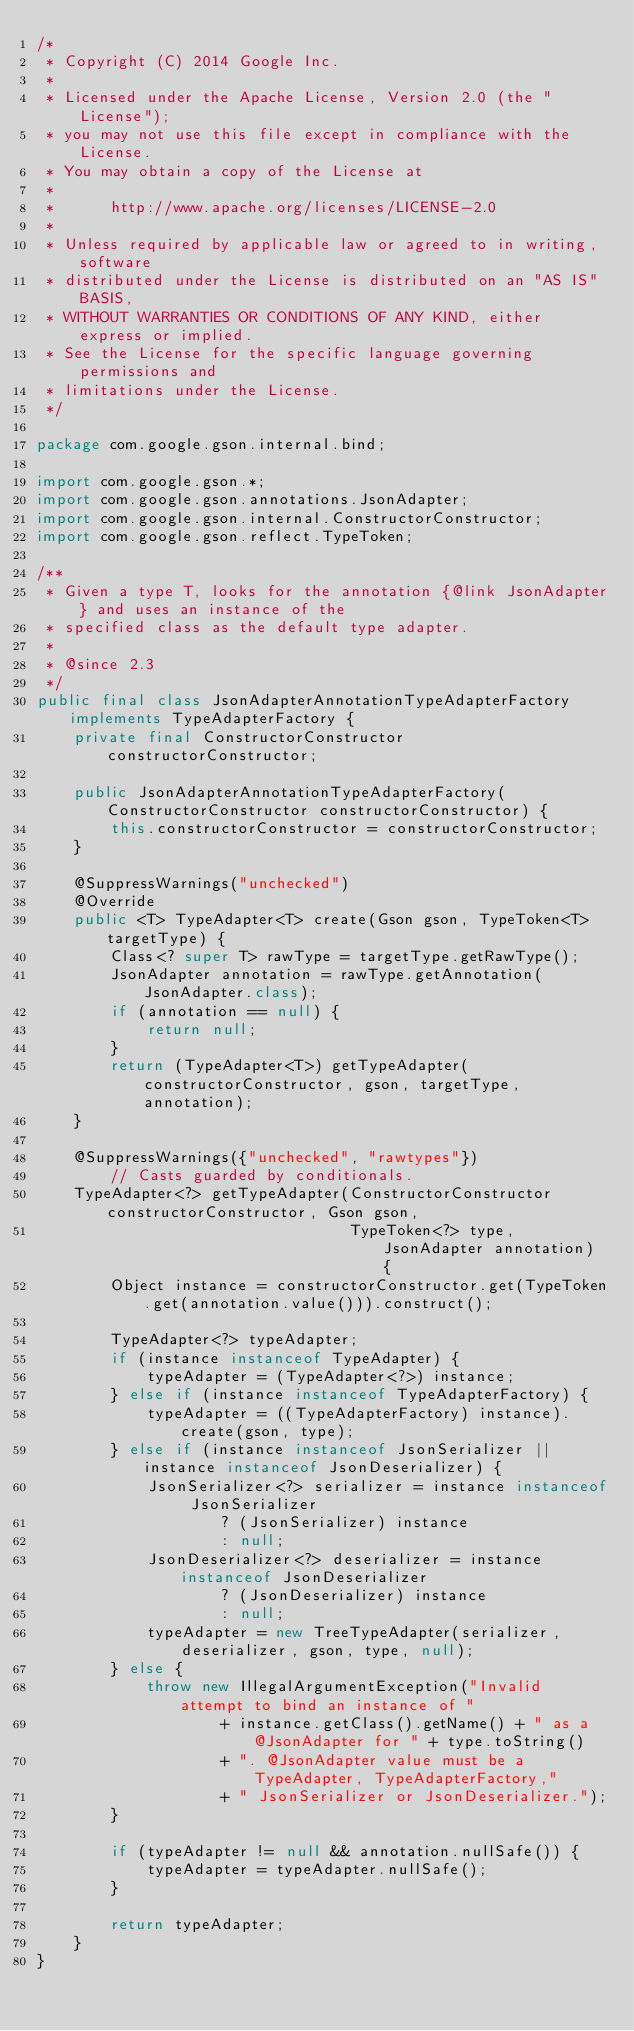Convert code to text. <code><loc_0><loc_0><loc_500><loc_500><_Java_>/*
 * Copyright (C) 2014 Google Inc.
 *
 * Licensed under the Apache License, Version 2.0 (the "License");
 * you may not use this file except in compliance with the License.
 * You may obtain a copy of the License at
 *
 *      http://www.apache.org/licenses/LICENSE-2.0
 *
 * Unless required by applicable law or agreed to in writing, software
 * distributed under the License is distributed on an "AS IS" BASIS,
 * WITHOUT WARRANTIES OR CONDITIONS OF ANY KIND, either express or implied.
 * See the License for the specific language governing permissions and
 * limitations under the License.
 */

package com.google.gson.internal.bind;

import com.google.gson.*;
import com.google.gson.annotations.JsonAdapter;
import com.google.gson.internal.ConstructorConstructor;
import com.google.gson.reflect.TypeToken;

/**
 * Given a type T, looks for the annotation {@link JsonAdapter} and uses an instance of the
 * specified class as the default type adapter.
 *
 * @since 2.3
 */
public final class JsonAdapterAnnotationTypeAdapterFactory implements TypeAdapterFactory {
    private final ConstructorConstructor constructorConstructor;

    public JsonAdapterAnnotationTypeAdapterFactory(ConstructorConstructor constructorConstructor) {
        this.constructorConstructor = constructorConstructor;
    }

    @SuppressWarnings("unchecked")
    @Override
    public <T> TypeAdapter<T> create(Gson gson, TypeToken<T> targetType) {
        Class<? super T> rawType = targetType.getRawType();
        JsonAdapter annotation = rawType.getAnnotation(JsonAdapter.class);
        if (annotation == null) {
            return null;
        }
        return (TypeAdapter<T>) getTypeAdapter(constructorConstructor, gson, targetType, annotation);
    }

    @SuppressWarnings({"unchecked", "rawtypes"})
        // Casts guarded by conditionals.
    TypeAdapter<?> getTypeAdapter(ConstructorConstructor constructorConstructor, Gson gson,
                                  TypeToken<?> type, JsonAdapter annotation) {
        Object instance = constructorConstructor.get(TypeToken.get(annotation.value())).construct();

        TypeAdapter<?> typeAdapter;
        if (instance instanceof TypeAdapter) {
            typeAdapter = (TypeAdapter<?>) instance;
        } else if (instance instanceof TypeAdapterFactory) {
            typeAdapter = ((TypeAdapterFactory) instance).create(gson, type);
        } else if (instance instanceof JsonSerializer || instance instanceof JsonDeserializer) {
            JsonSerializer<?> serializer = instance instanceof JsonSerializer
                    ? (JsonSerializer) instance
                    : null;
            JsonDeserializer<?> deserializer = instance instanceof JsonDeserializer
                    ? (JsonDeserializer) instance
                    : null;
            typeAdapter = new TreeTypeAdapter(serializer, deserializer, gson, type, null);
        } else {
            throw new IllegalArgumentException("Invalid attempt to bind an instance of "
                    + instance.getClass().getName() + " as a @JsonAdapter for " + type.toString()
                    + ". @JsonAdapter value must be a TypeAdapter, TypeAdapterFactory,"
                    + " JsonSerializer or JsonDeserializer.");
        }

        if (typeAdapter != null && annotation.nullSafe()) {
            typeAdapter = typeAdapter.nullSafe();
        }

        return typeAdapter;
    }
}
</code> 